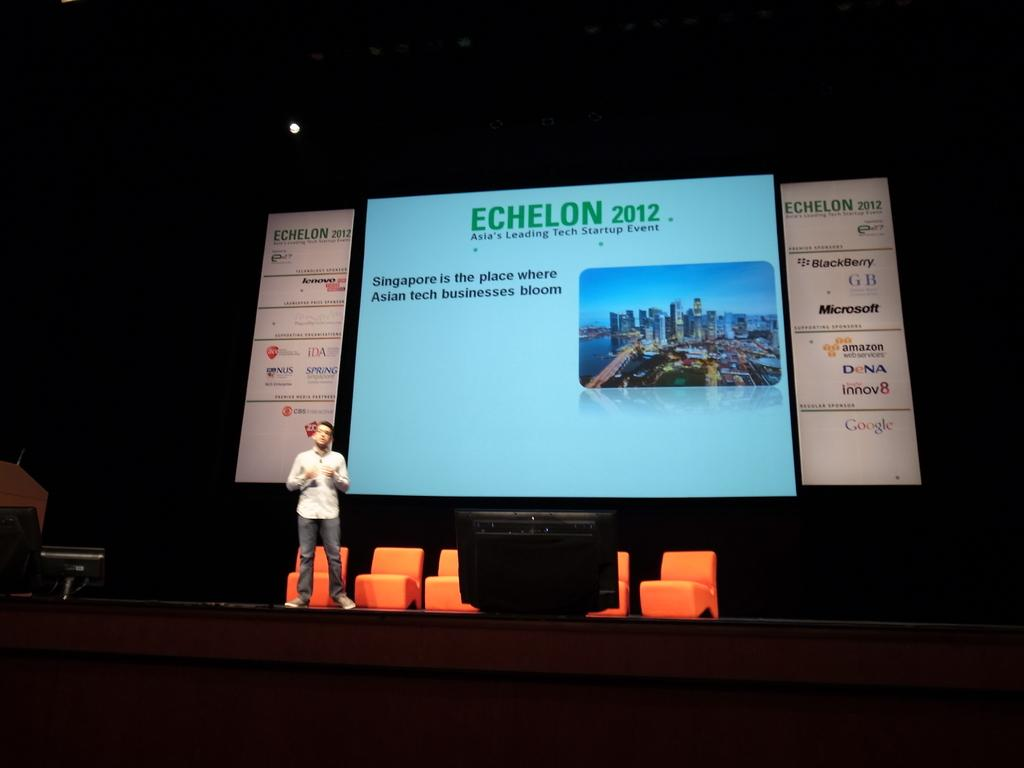<image>
Provide a brief description of the given image. a lit up conference screen reading Echelon 2012 